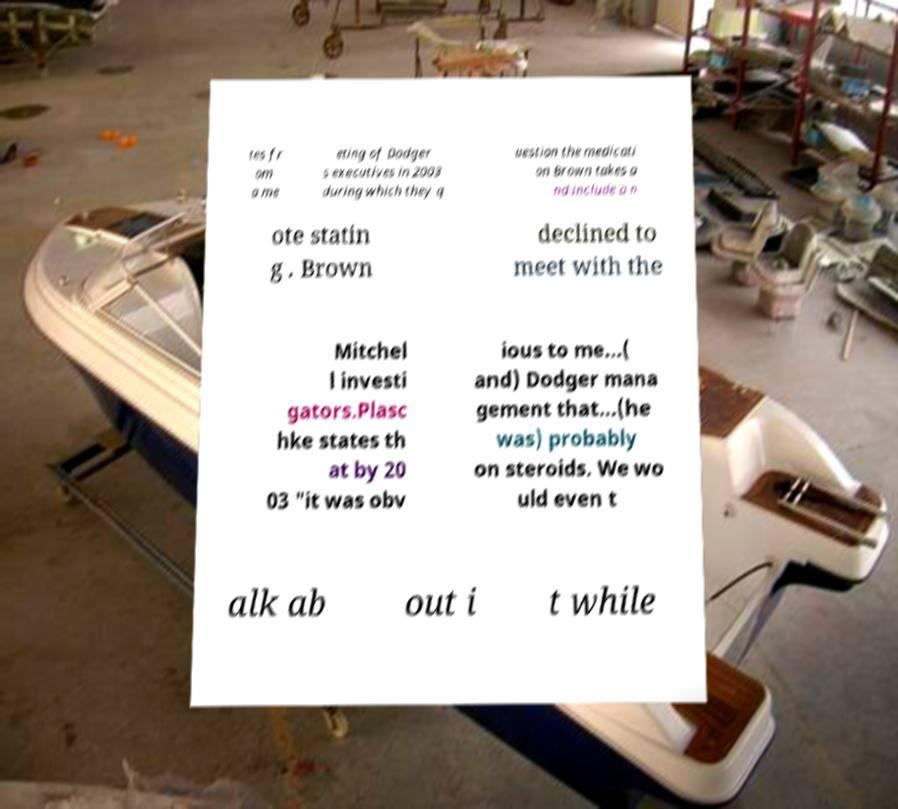Can you read and provide the text displayed in the image?This photo seems to have some interesting text. Can you extract and type it out for me? tes fr om a me eting of Dodger s executives in 2003 during which they q uestion the medicati on Brown takes a nd include a n ote statin g . Brown declined to meet with the Mitchel l investi gators.Plasc hke states th at by 20 03 "it was obv ious to me...( and) Dodger mana gement that...(he was) probably on steroids. We wo uld even t alk ab out i t while 